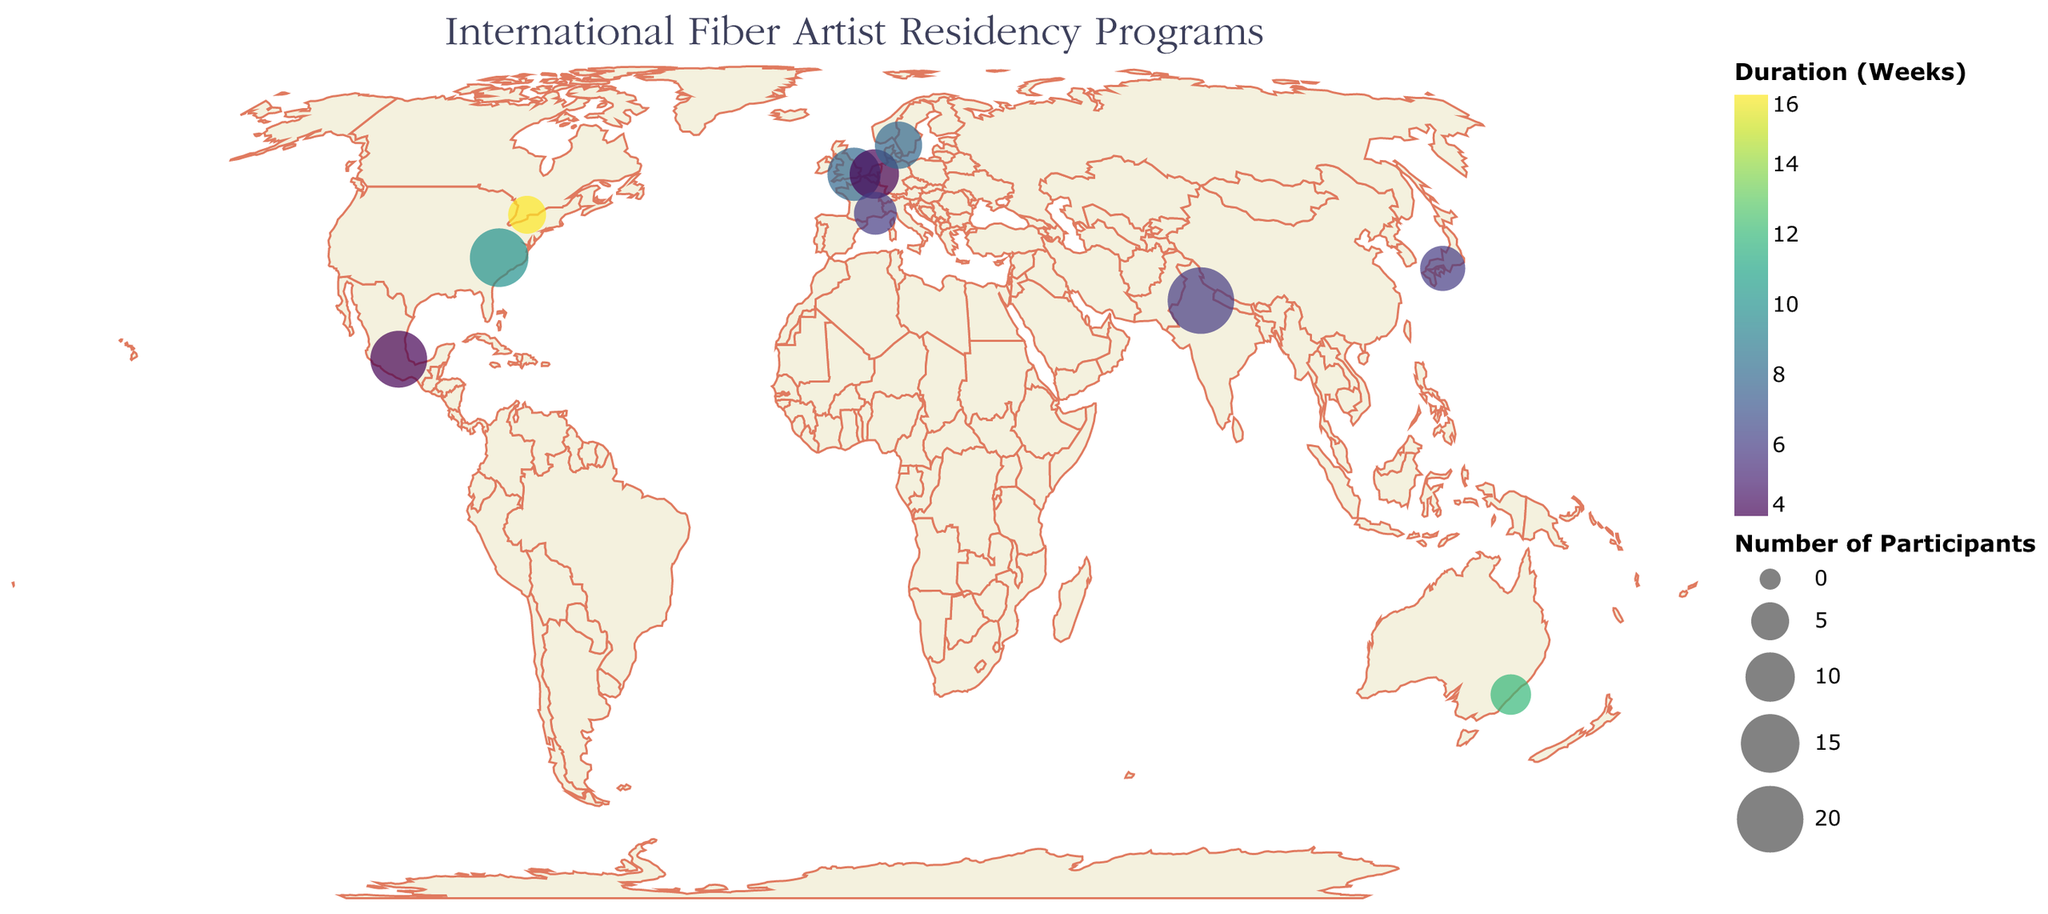How many artist residency programs are shown on the map? Count the number of circles on the map, each representing a program.
Answer: 10 Which residency program has the longest duration? Look for the largest circle on the map with the darkest color.
Answer: Harbourfront Centre Craft Residency What is the range of participant numbers in these residency programs? Find the smallest and largest circle sizes on the map and subtract the smallest number from the largest.
Answer: 5 to 20 Which program is located in Japan? Look at the tooltip or map marker at the geographic coordinates corresponding to Japan.
Answer: Awagami Factory Artist-in-Residence How does the duration of the Australian program compare to the one in the United Kingdom? Use the color legend to compare the color representing duration weeks for both marker points on the map.
Answer: Australia: 12 weeks, United Kingdom: 8 weeks Which residency program has the most participants? Identify the largest circle on the map by size.
Answer: Sanskriti Kendra Residency What is the average duration of all the residency programs? Add all the durations and divide by the number of programs: (8+6+10+4+12+6+8+4+6+16)/10.
Answer: 8 weeks Which programs have durations shorter than 8 weeks? Check the color of each circle on the map and compare them to the color representing 8 weeks or less.
Answer: Awagami Factory Artist-in-Residence, TextielLab Residency, Sanskriti Kendra Residency, Arquetopia Foundation Residency, Villa Datris Foundation Residency Are there any programs in North America? If so, identify them. Look at the circles located in the North American region on the map.
Answer: Penland School of Craft Residency, Harbourfront Centre Craft Residency How many programs are in Europe? Count the circles in the European region of the map.
Answer: 3 